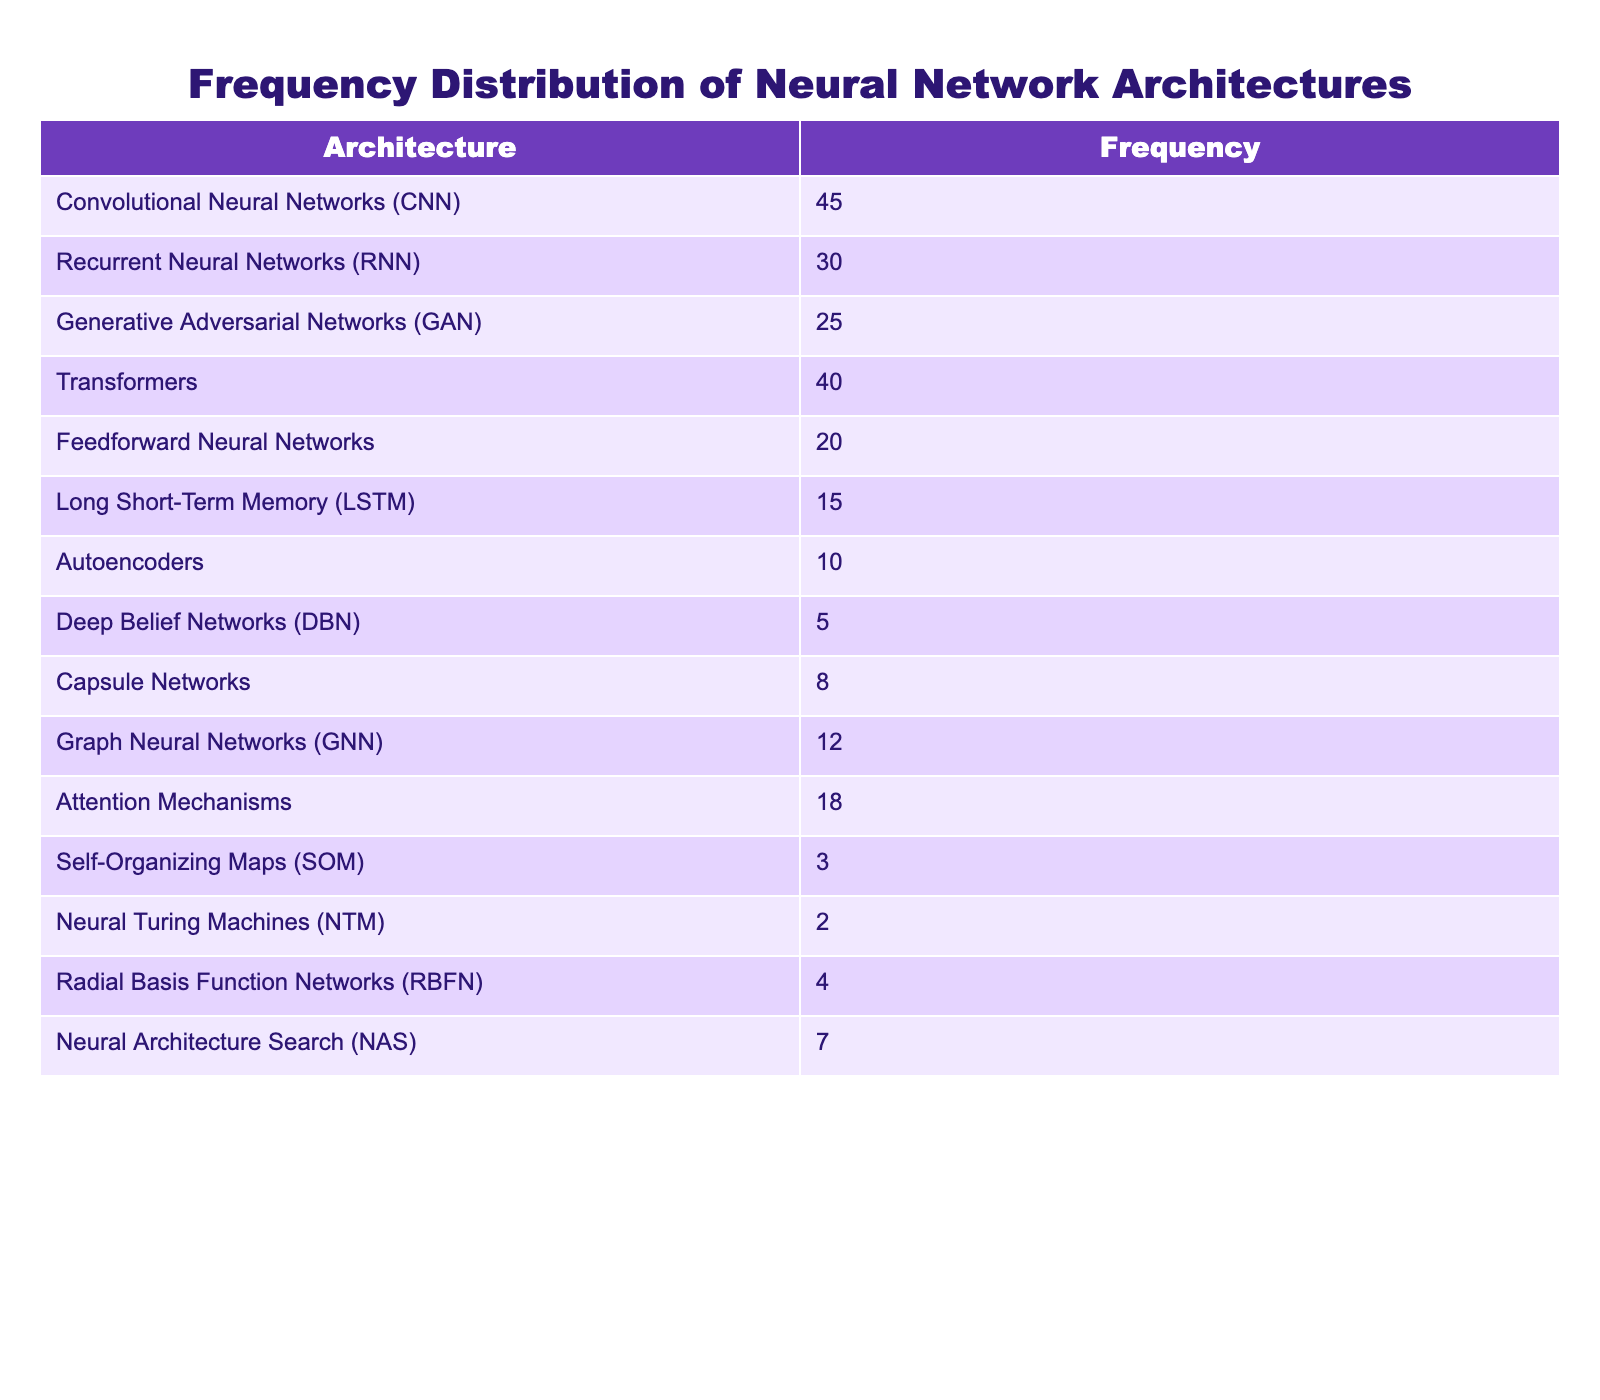What neural network architecture has the highest frequency? Reviewing the frequency column in the table, Convolutional Neural Networks (CNN) is the entry with the highest frequency at 45.
Answer: Convolutional Neural Networks (CNN) How many architectures have a frequency greater than 20? Counting the architectures listed with a frequency greater than 20, we find five: CNN (45), Transformers (40), RNN (30), GAN (25), and Attention Mechanisms (18).
Answer: 5 What is the difference in frequency between the highest and lowest architecture? The highest frequency is 45 (CNN), and the lowest frequency is 2 (Neural Turing Machines). The difference is calculated as 45 - 2 = 43.
Answer: 43 Are there more Recurrent Neural Networks (RNN) used than Autoencoders? Comparing the frequencies, RNN has a frequency of 30 while Autoencoders have 10, indicating that RNNs are used more in research papers.
Answer: Yes What is the average frequency of the neural network architectures in the table? To find the average, sum the frequencies: 45 + 30 + 25 + 40 + 20 + 15 + 10 + 5 + 8 + 12 + 18 + 3 + 2 + 4 + 7 =  305, and divide by the number of architectures (15). Average = 305/15 = 20.33.
Answer: 20.33 Which architecture has a frequency closest to the median value? First, identify the median frequency: After sorting the frequencies (2, 3, 4, 5, 7, 8, 10, 12, 15, 18, 20, 25, 30, 40, 45), the median (8th value) is 12. The architecture that matches or is closest is Graph Neural Networks, which has a frequency of 12.
Answer: Graph Neural Networks (GNN) Is there an architecture that has a frequency of 8? By scanning the table, Capsule Networks is noted to have a frequency of 8.
Answer: Yes How many architectures have a frequency under 10? Evaluating the table, the architectures with a frequency under 10 are DBN (5), SOM (3), NTM (2), and RBFN (4), totaling four architectures.
Answer: 4 